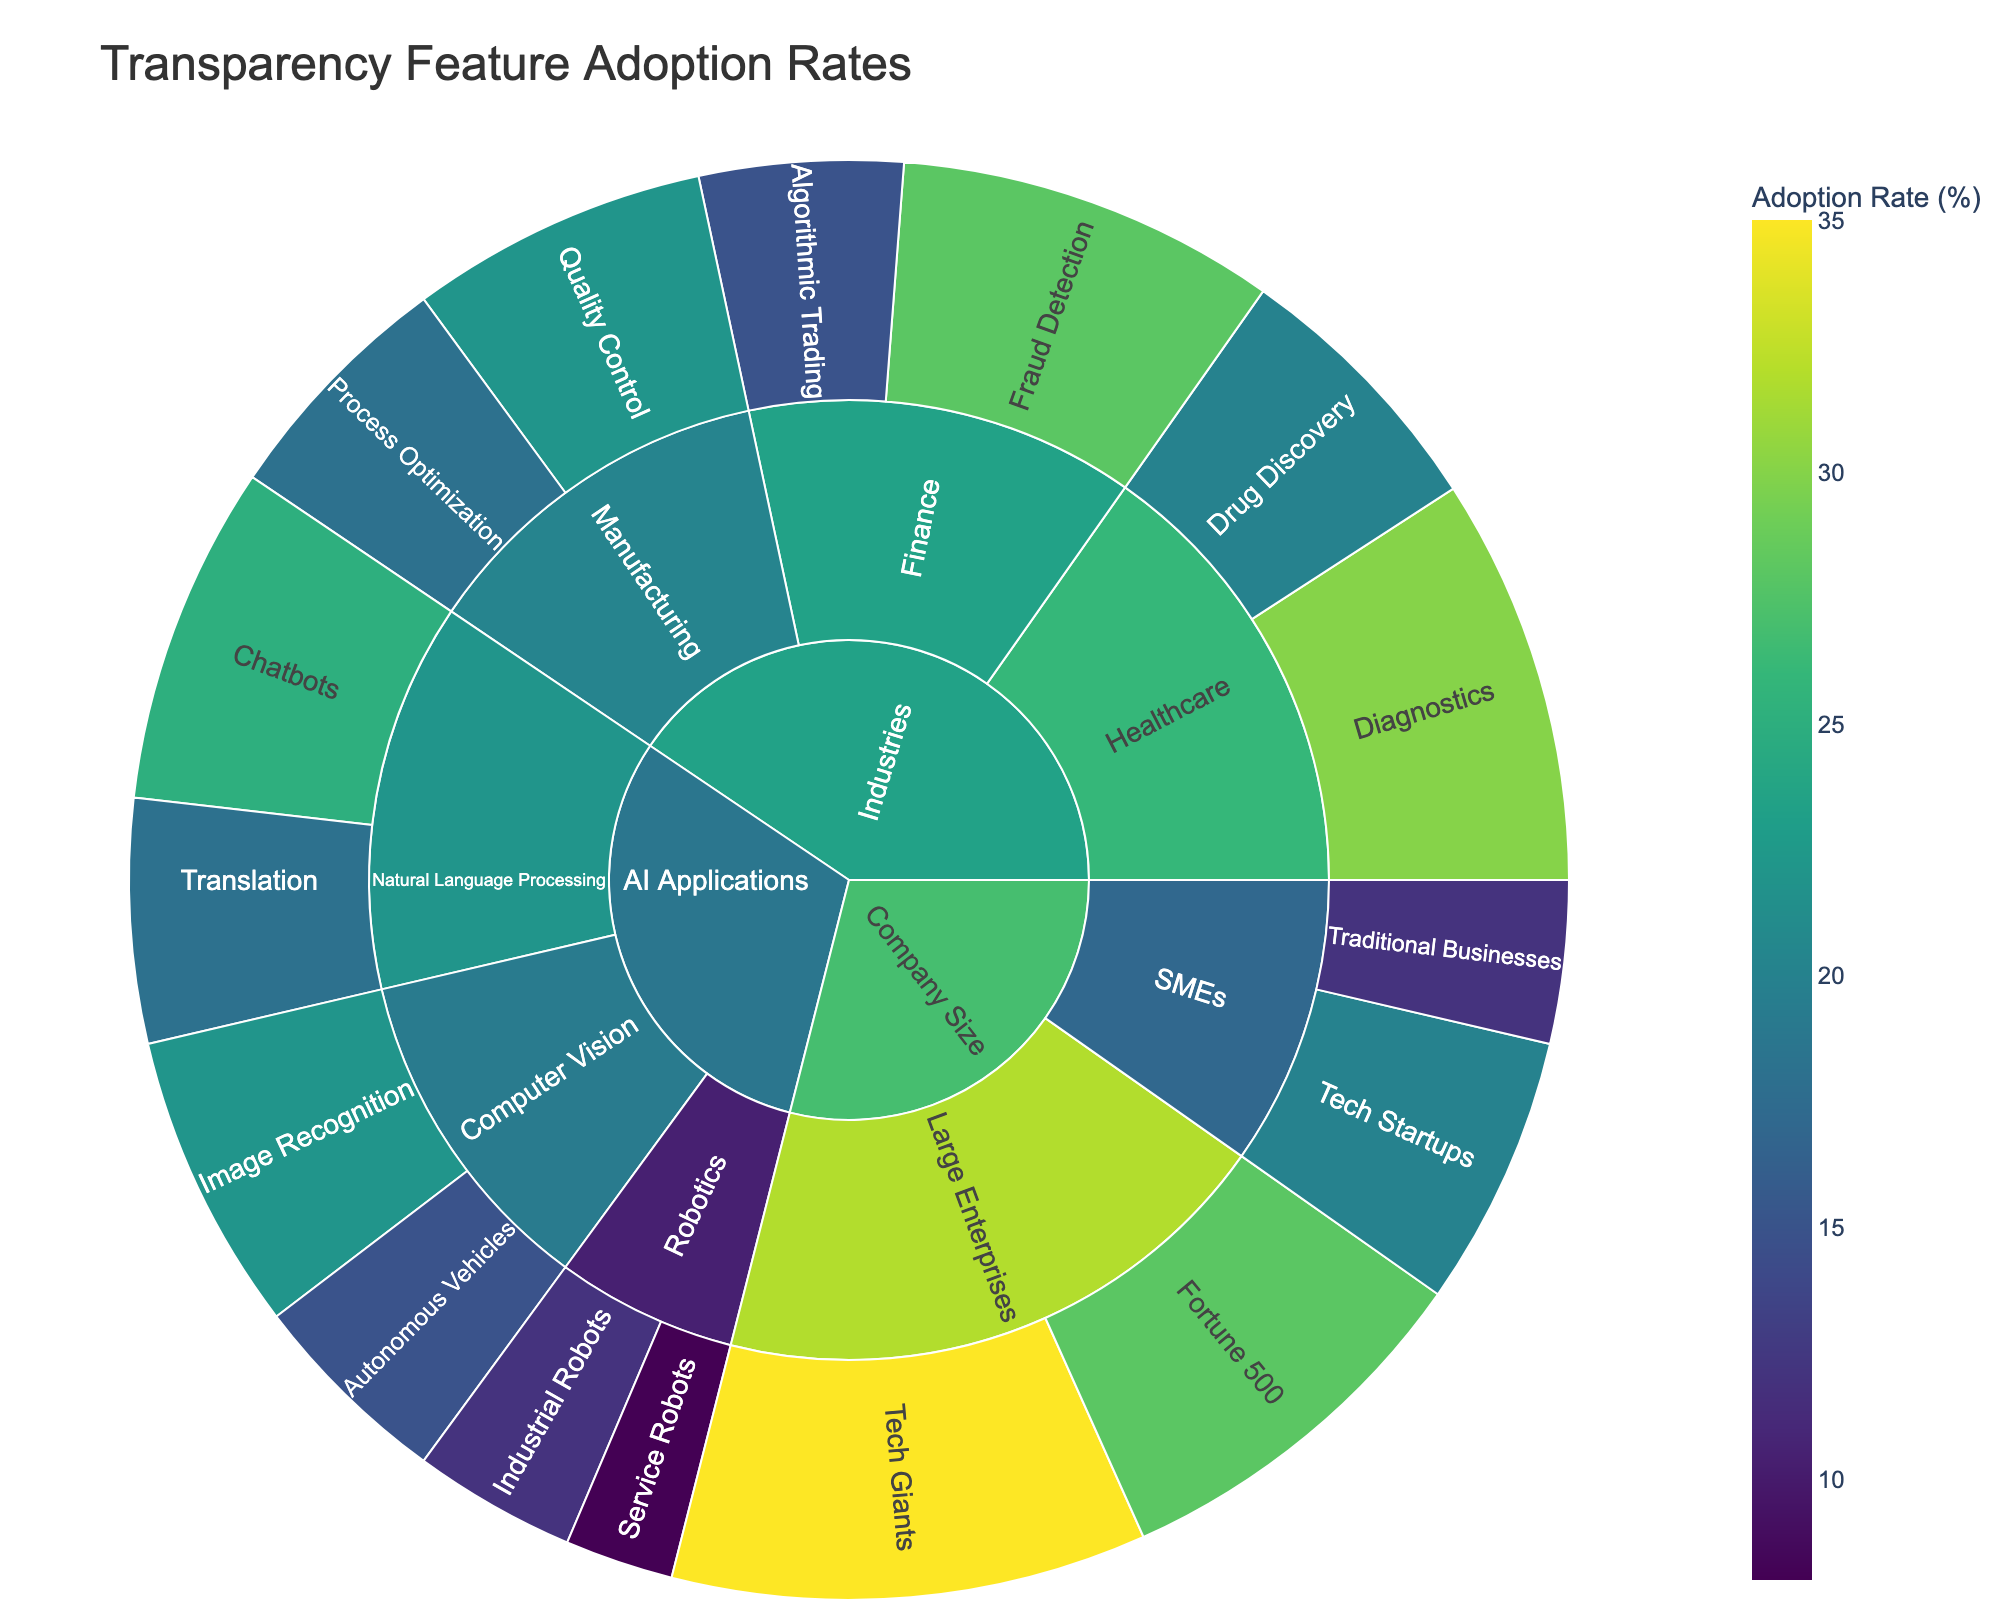What's the adoption rate of chatbots in Natural Language Processing? To find the adoption rate for chatbots, locate the "AI Applications" category, follow the path through "Natural Language Processing," and then find "Chatbots." The value is displayed there.
Answer: 25% Which subcategory in Healthcare has the higher adoption rate? Within the "Healthcare" subcategory, compare the values for "Diagnostics" and "Drug Discovery." The one with the higher value is the answer.
Answer: Diagnostics What is the combined adoption rate for Tech Giants and Fortune 500 in the Large Enterprises subcategory? Add the values for "Tech Giants" and "Fortune 500" under the "Large Enterprises" subcategory. The values are 35 and 28, respectively.
Answer: 63% How does the adoption rate of Image Recognition compare with Autonomous Vehicles in Computer Vision? Under the "Computer Vision" subcategory, compare the adoption rates of "Image Recognition" (22) and "Autonomous Vehicles" (15).
Answer: Image Recognition is higher by 7 Which category has the highest total adoption rate? Sum the adoption rates for all subcategories under "AI Applications," "Industries," and "Company Size." Compare the sums to find the highest total.
Answer: Company Size What is the adoption rate for Process Optimization in Manufacturing? Locate the "Industries" category, follow it to "Manufacturing," and then examine the "Process Optimization" subcategory. The adoption rate is displayed there.
Answer: 18% How does the adoption rate of Industrial Robots compare with Service Robots in Robotics? Within the "Robotics" subcategory, compare the values for "Industrial Robots" (12) and "Service Robots" (8).
Answer: Industrial Robots is higher by 4 Which AI application has the lowest adoption rate? Look within the "AI Applications" category and compare all subsubcategories' values: "Chatbots," "Translation," "Image Recognition," "Autonomous Vehicles," "Industrial Robots," and "Service Robots." Identify the lowest value.
Answer: Service Robots What’s the adoption rate for Diagnostics compared to Fraud Detection? Compare the "Healthcare" sub-subcategory "Diagnostics" (30) with the "Finance" sub-subcategory "Fraud Detection" (28).
Answer: Diagnostics is higher by 2 What's the average adoption rate for the Finance subcategory? Add the values for "Fraud Detection" (28) and "Algorithmic Trading" (15), then divide by 2 to find the average.
Answer: 21.5% 